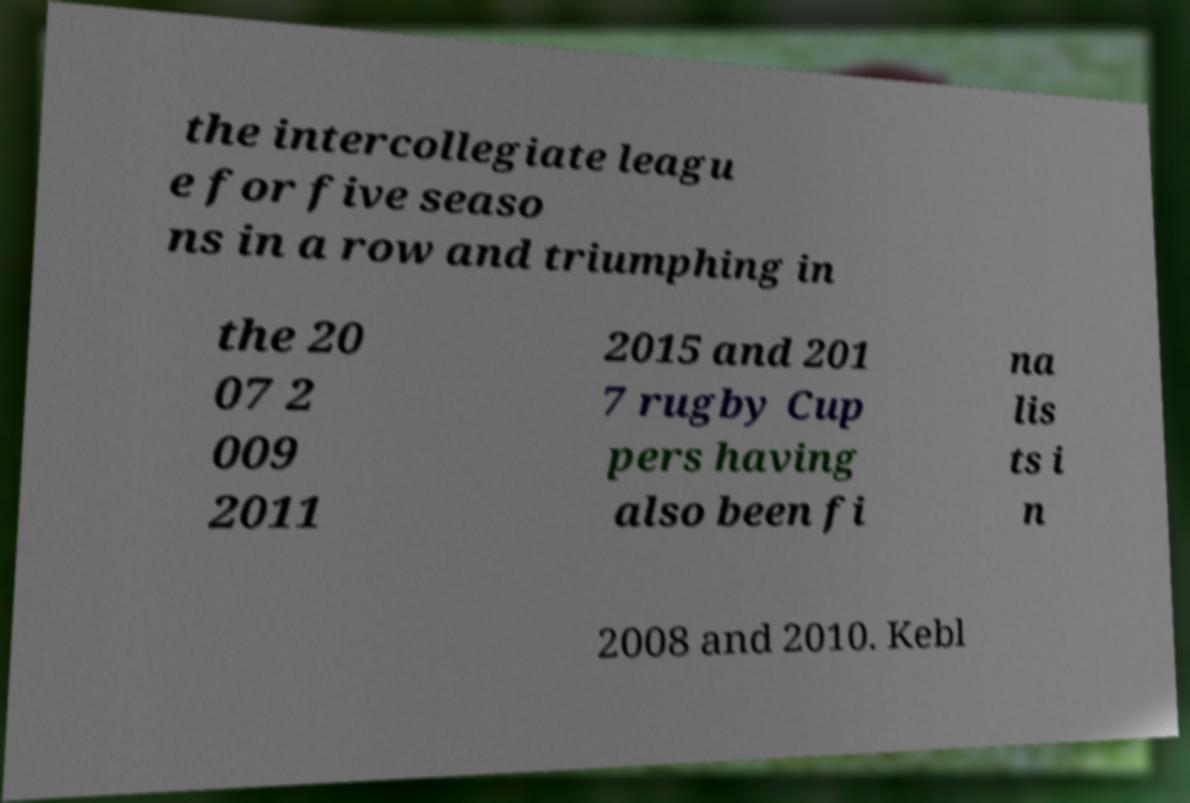Could you extract and type out the text from this image? the intercollegiate leagu e for five seaso ns in a row and triumphing in the 20 07 2 009 2011 2015 and 201 7 rugby Cup pers having also been fi na lis ts i n 2008 and 2010. Kebl 